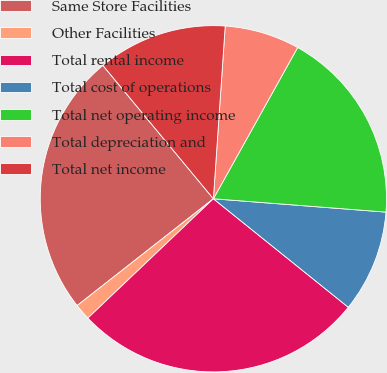<chart> <loc_0><loc_0><loc_500><loc_500><pie_chart><fcel>Same Store Facilities<fcel>Other Facilities<fcel>Total rental income<fcel>Total cost of operations<fcel>Total net operating income<fcel>Total depreciation and<fcel>Total net income<nl><fcel>24.57%<fcel>1.52%<fcel>27.12%<fcel>9.55%<fcel>18.14%<fcel>7.0%<fcel>12.1%<nl></chart> 